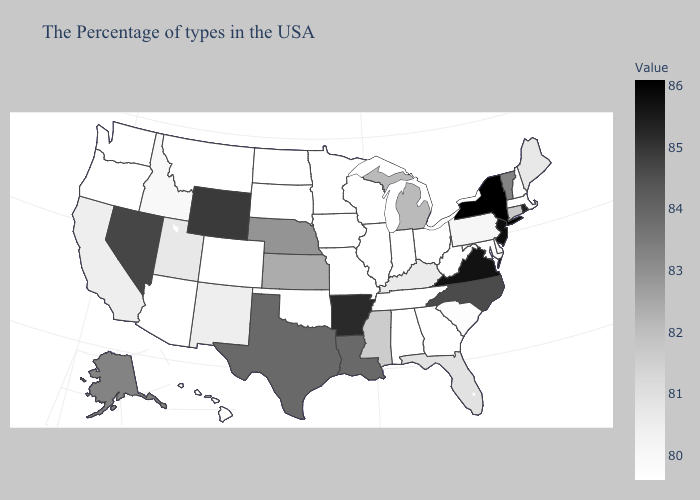Among the states that border Oklahoma , which have the lowest value?
Concise answer only. Missouri, Colorado. Does New Jersey have the highest value in the USA?
Quick response, please. No. Does West Virginia have the lowest value in the USA?
Be succinct. Yes. Which states have the highest value in the USA?
Short answer required. New York. Which states have the lowest value in the South?
Short answer required. Maryland, West Virginia, Georgia, Alabama, Tennessee, Oklahoma. Does New Jersey have the lowest value in the Northeast?
Quick response, please. No. Which states have the lowest value in the MidWest?
Short answer required. Ohio, Indiana, Wisconsin, Illinois, Missouri, Minnesota, Iowa, South Dakota, North Dakota. Does Rhode Island have the lowest value in the USA?
Quick response, please. No. Among the states that border Kentucky , which have the lowest value?
Be succinct. West Virginia, Ohio, Indiana, Tennessee, Illinois, Missouri. 